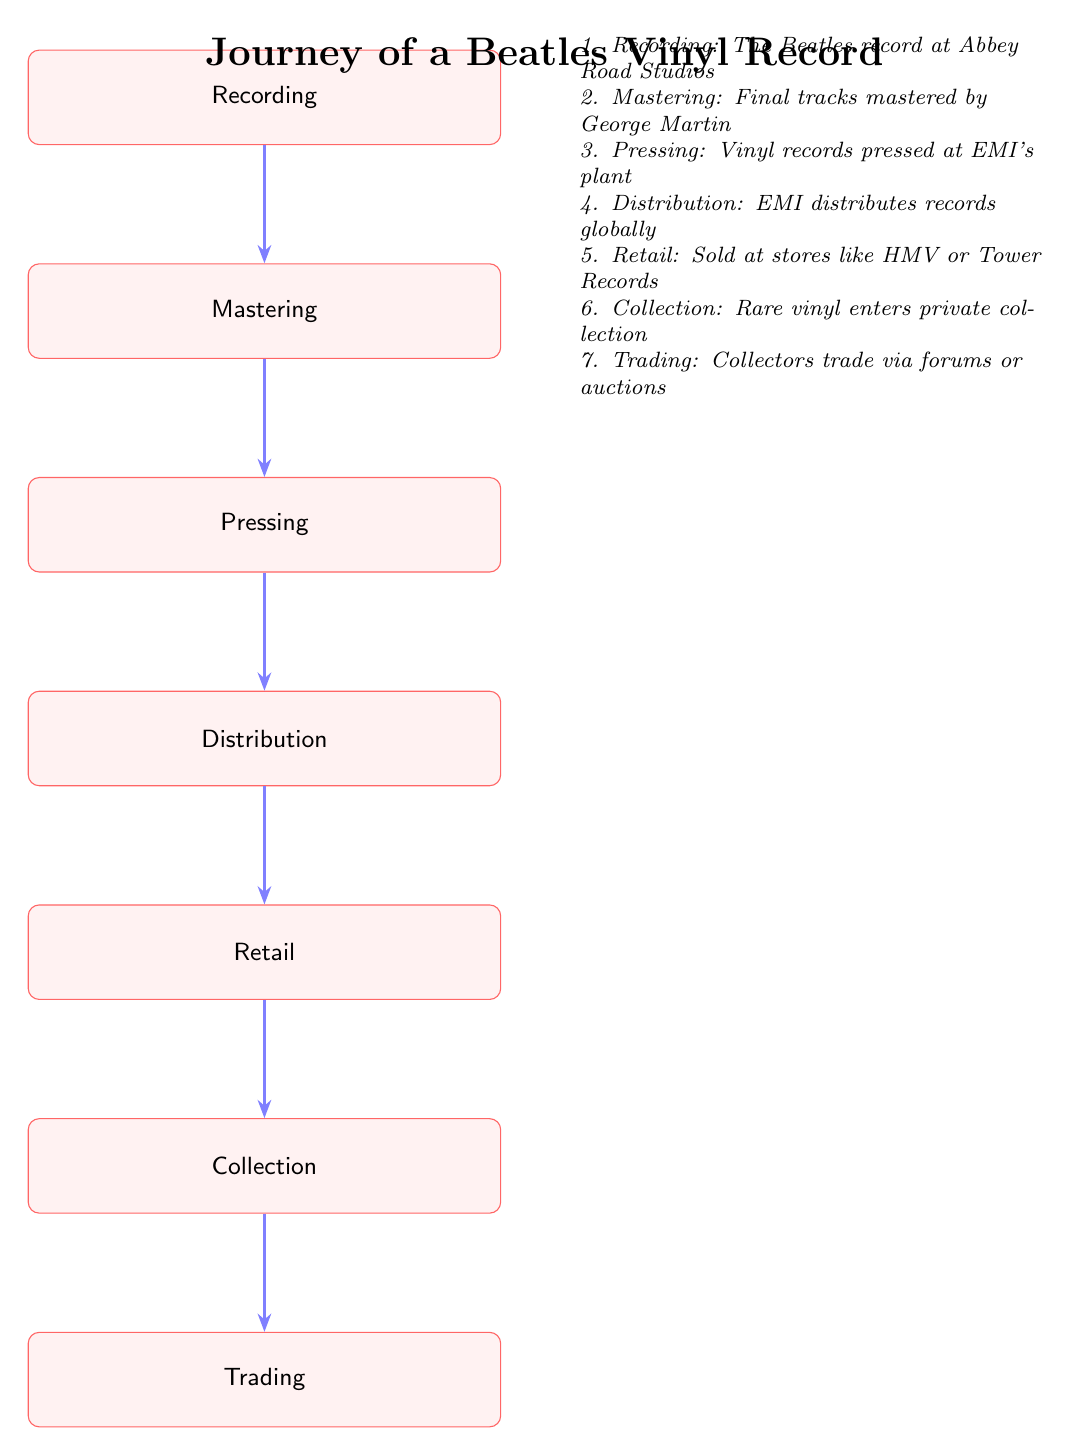What is the first step in the journey? The first step in the journey is labeled as 'Recording' in the diagram, indicating that it is the initial phase where the Beatles start their process.
Answer: Recording How many total steps are shown in the diagram? By counting the distinct nodes in the diagram, we see there are 7 steps in total from 'Recording' to 'Trading'.
Answer: 7 What is the final stage of the journey? The last stage listed in the diagram is 'Trading', where collectors exchange vinyl records, representing the culmination of the previous steps.
Answer: Trading Who mastered the final tracks? The text accompanying the diagram states that the final tracks were mastered by George Martin, highlighting his critical role in this process.
Answer: George Martin What process comes after 'Pressing'? Following 'Pressing', the next step in the diagram is 'Distribution', indicating that after vinyl records are pressed, they are distributed to various outlets.
Answer: Distribution What is the retailer mentioned for selling the records? The diagram names 'HMV' (His Master's Voice) as one of the retailers, indicating a specific store where the records could be purchased.
Answer: HMV In which stage does the vinyl enter private collections? The stage where vinyl enters private collections is labeled as 'Collection', indicating that this is where rare records are kept by enthusiasts.
Answer: Collection What happens after 'Distribution' in the diagram flow? After 'Distribution', the records move to the 'Retail' stage where they are made available for consumers to buy physically.
Answer: Retail What is emphasized about trading in the diagram? The diagram states that 'Collectors trade via forums or auctions', emphasizing the community aspect and methods of exchanging rare records among collectors.
Answer: forums or auctions 